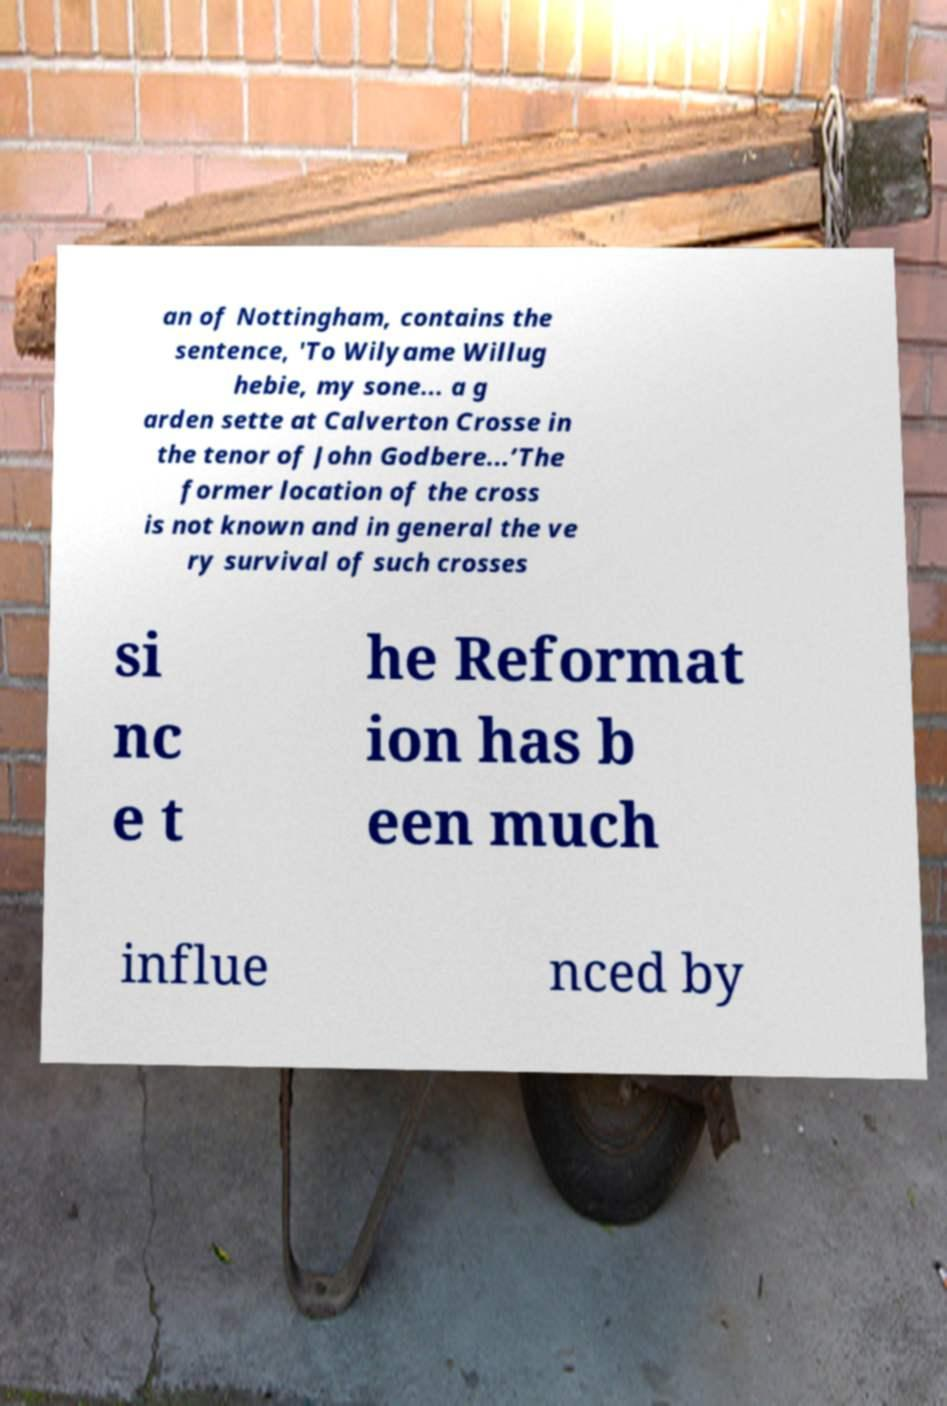Can you accurately transcribe the text from the provided image for me? an of Nottingham, contains the sentence, 'To Wilyame Willug hebie, my sone... a g arden sette at Calverton Crosse in the tenor of John Godbere...’The former location of the cross is not known and in general the ve ry survival of such crosses si nc e t he Reformat ion has b een much influe nced by 